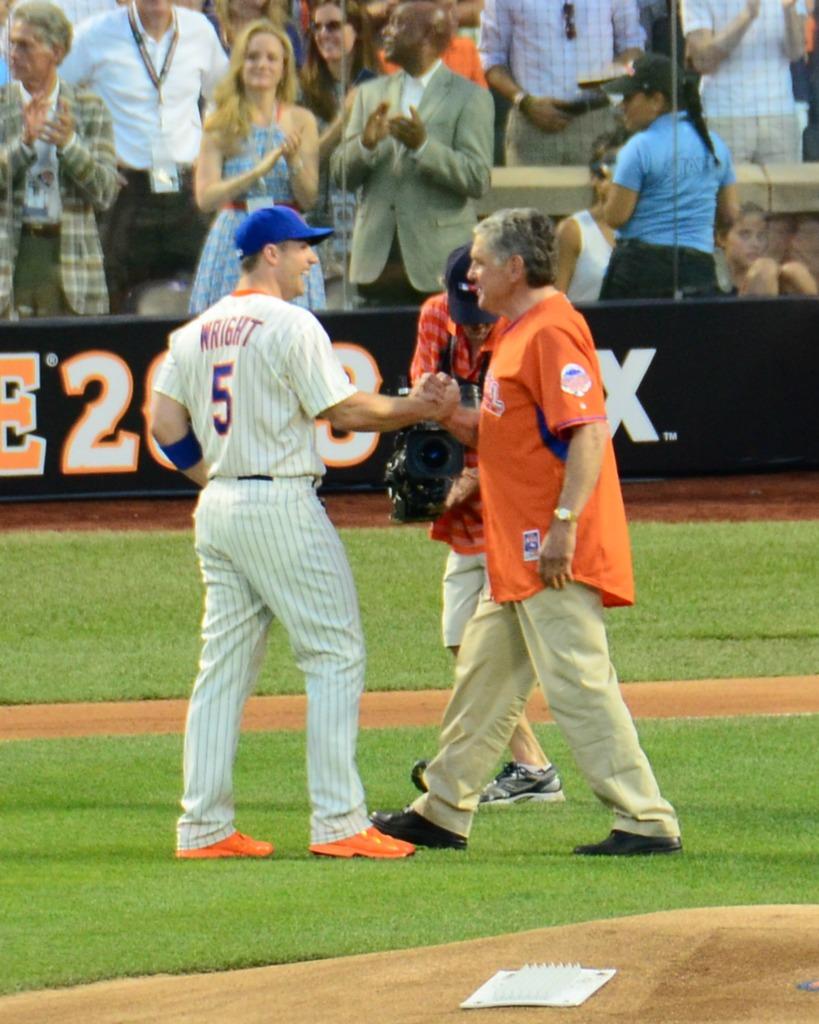Who wears the #5 jersey for new york baseball team?
Your answer should be very brief. Wright. What number is on the back wall?
Keep it short and to the point. 2. 